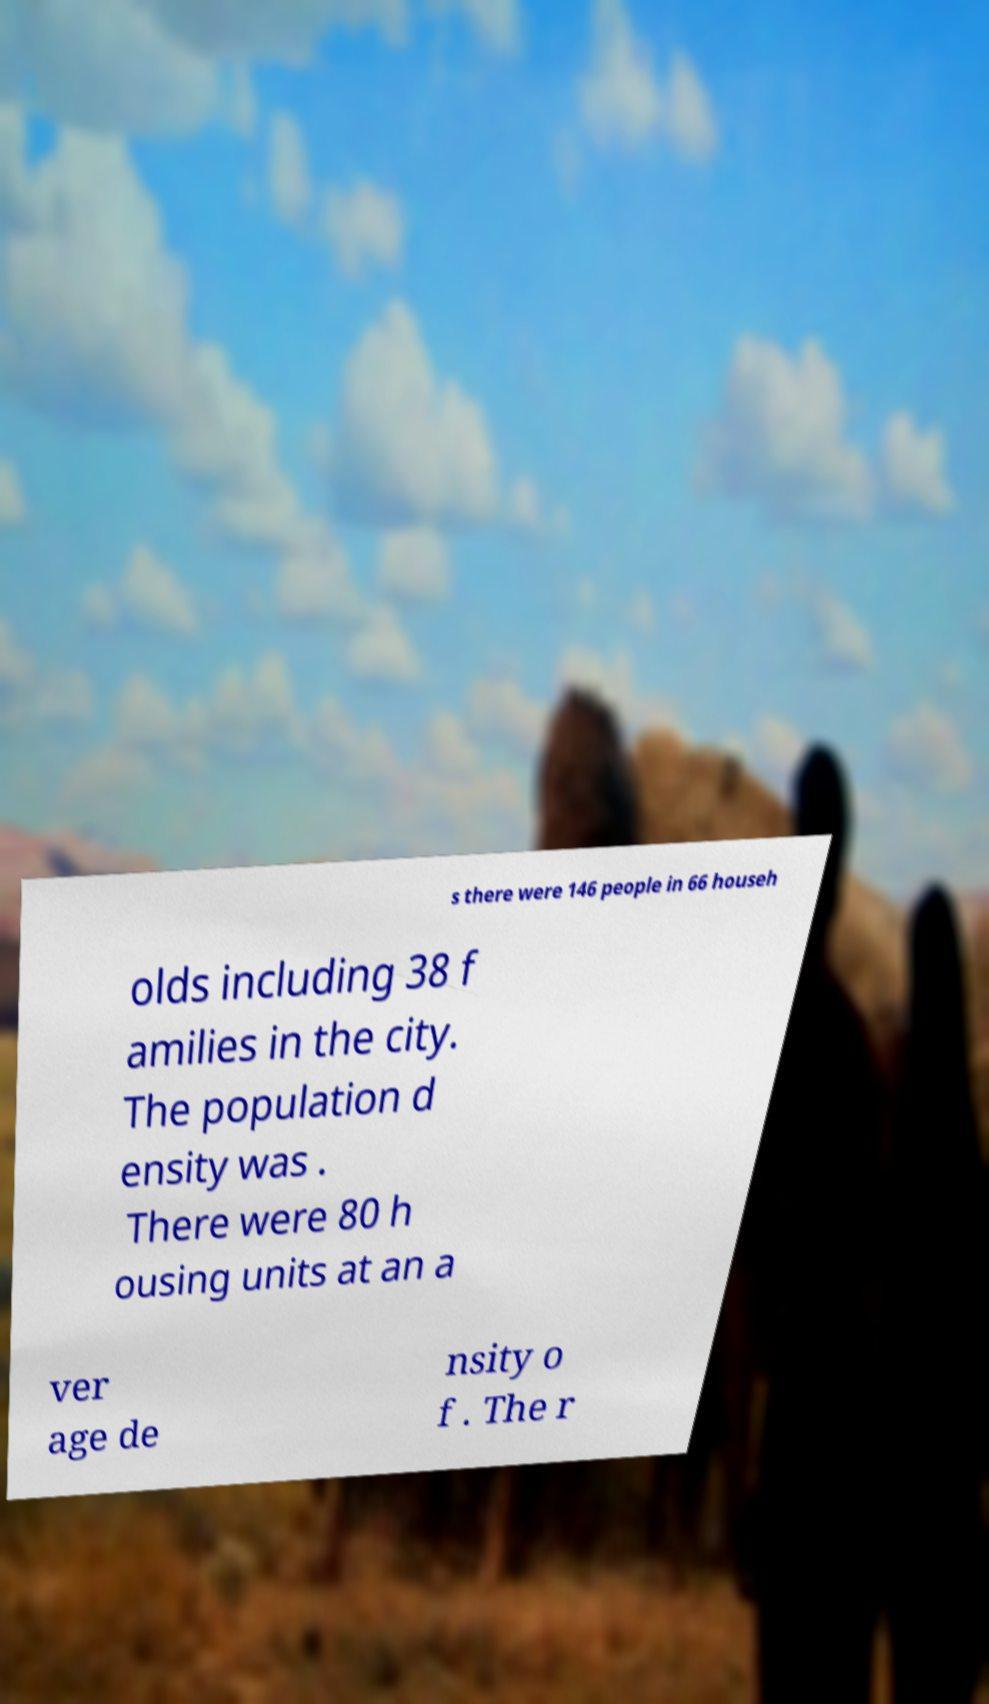There's text embedded in this image that I need extracted. Can you transcribe it verbatim? s there were 146 people in 66 househ olds including 38 f amilies in the city. The population d ensity was . There were 80 h ousing units at an a ver age de nsity o f . The r 